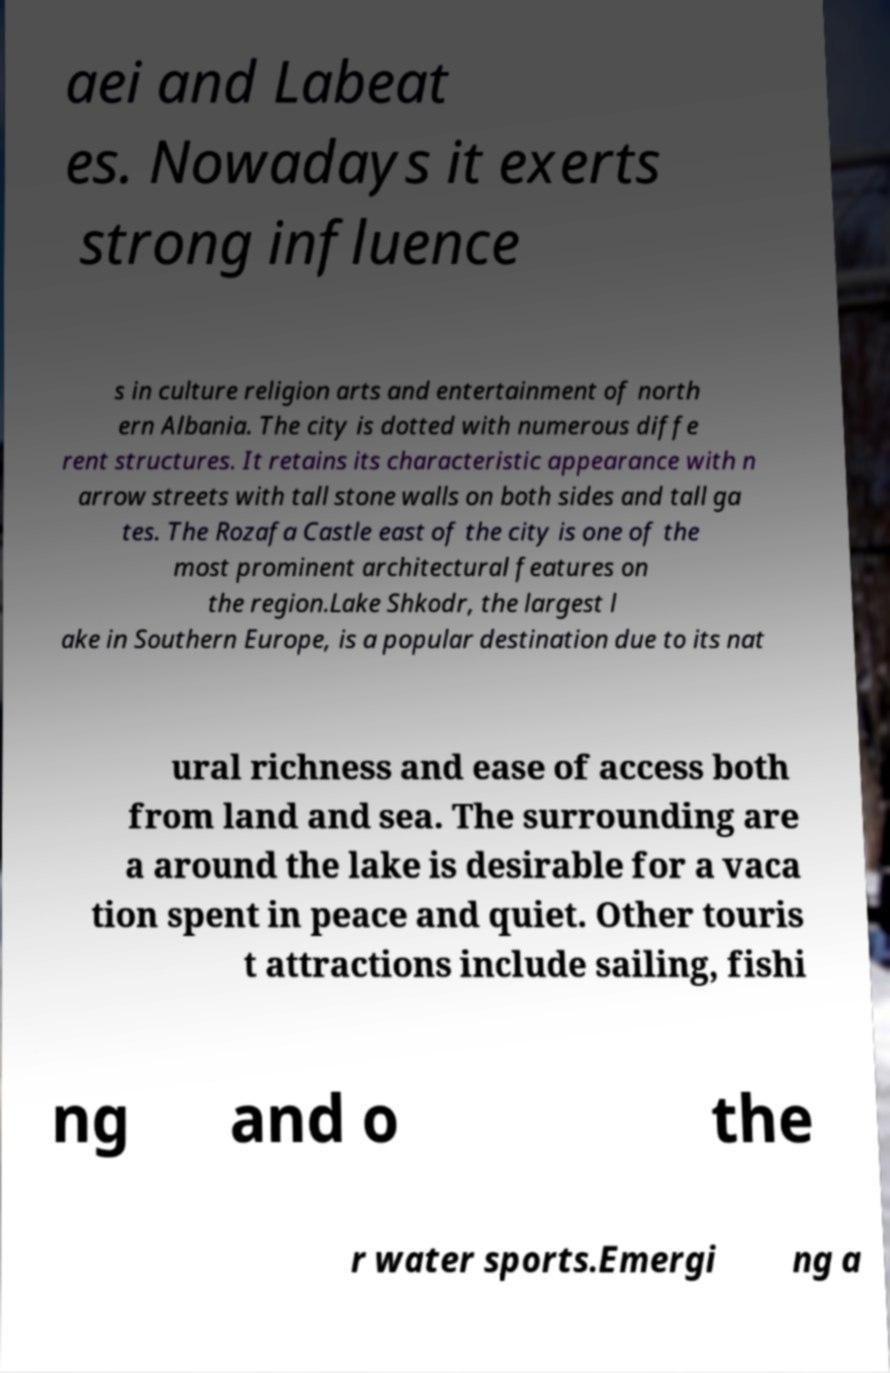Could you extract and type out the text from this image? aei and Labeat es. Nowadays it exerts strong influence s in culture religion arts and entertainment of north ern Albania. The city is dotted with numerous diffe rent structures. It retains its characteristic appearance with n arrow streets with tall stone walls on both sides and tall ga tes. The Rozafa Castle east of the city is one of the most prominent architectural features on the region.Lake Shkodr, the largest l ake in Southern Europe, is a popular destination due to its nat ural richness and ease of access both from land and sea. The surrounding are a around the lake is desirable for a vaca tion spent in peace and quiet. Other touris t attractions include sailing, fishi ng and o the r water sports.Emergi ng a 